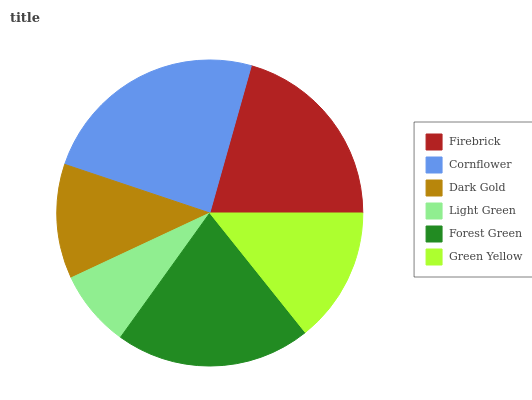Is Light Green the minimum?
Answer yes or no. Yes. Is Cornflower the maximum?
Answer yes or no. Yes. Is Dark Gold the minimum?
Answer yes or no. No. Is Dark Gold the maximum?
Answer yes or no. No. Is Cornflower greater than Dark Gold?
Answer yes or no. Yes. Is Dark Gold less than Cornflower?
Answer yes or no. Yes. Is Dark Gold greater than Cornflower?
Answer yes or no. No. Is Cornflower less than Dark Gold?
Answer yes or no. No. Is Firebrick the high median?
Answer yes or no. Yes. Is Green Yellow the low median?
Answer yes or no. Yes. Is Light Green the high median?
Answer yes or no. No. Is Firebrick the low median?
Answer yes or no. No. 